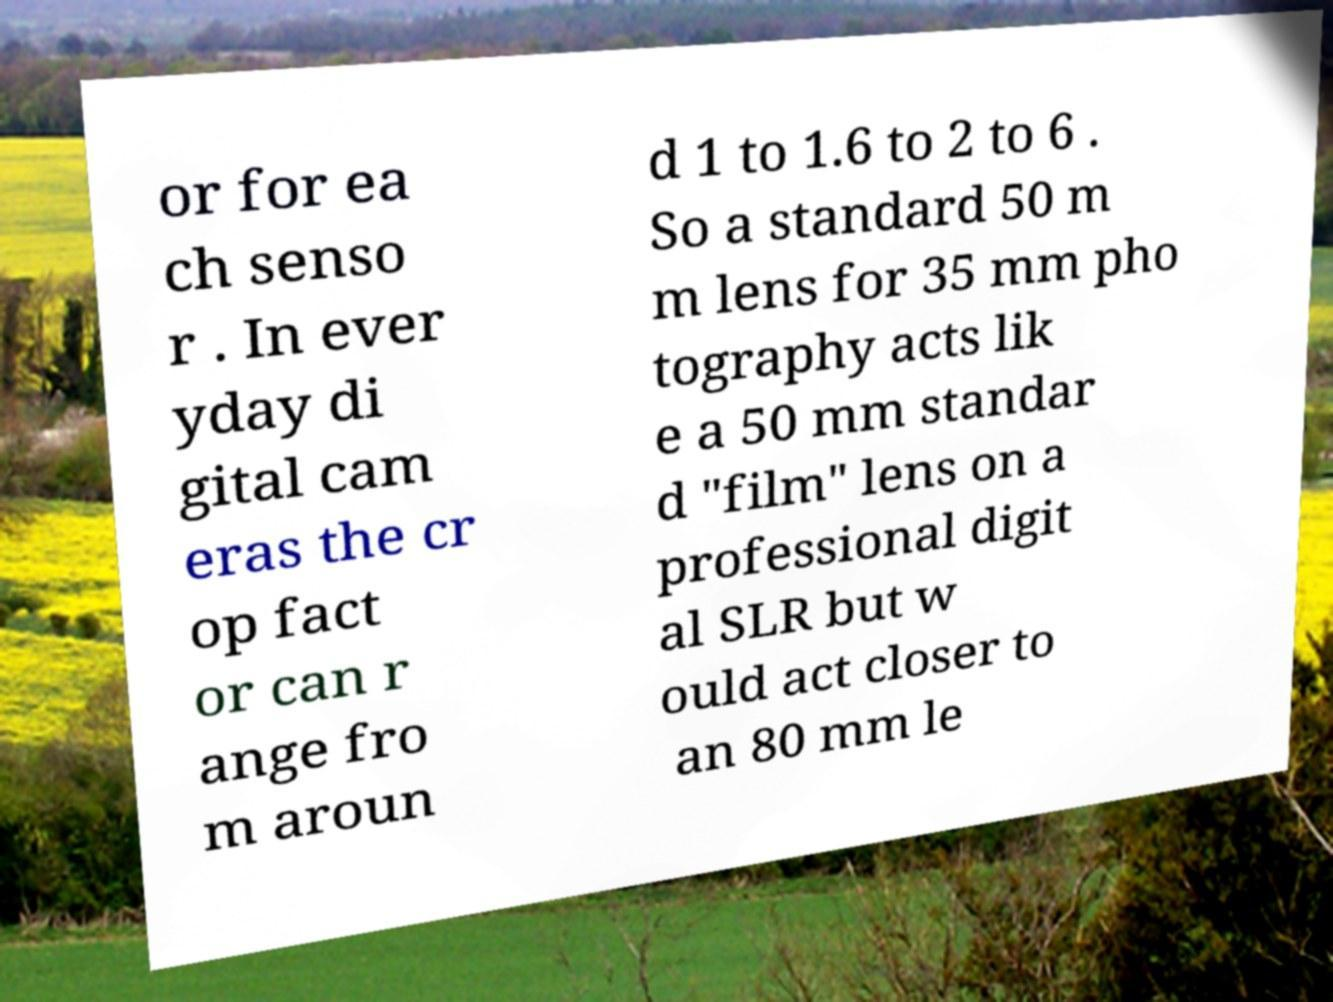Could you assist in decoding the text presented in this image and type it out clearly? or for ea ch senso r . In ever yday di gital cam eras the cr op fact or can r ange fro m aroun d 1 to 1.6 to 2 to 6 . So a standard 50 m m lens for 35 mm pho tography acts lik e a 50 mm standar d "film" lens on a professional digit al SLR but w ould act closer to an 80 mm le 